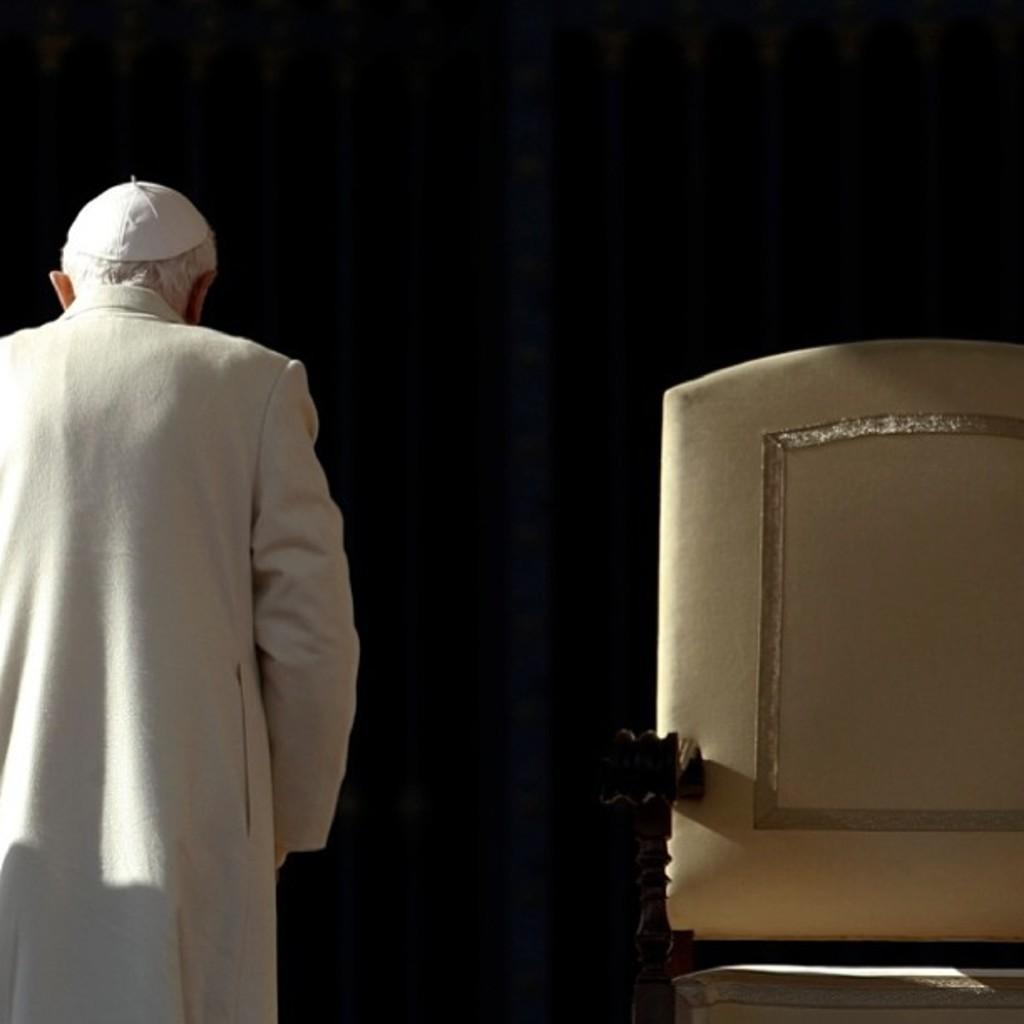What is the main subject of the image? The main subject of the image is a man standing. What is the man wearing on his head? The man is wearing a cap. What type of clothing is the man wearing on his upper body? The man is wearing a kurta. Can you describe any furniture in the image? There appears to be a chair in the image. What is the color scheme of the background in the image? The background of the image is dark. What type of linen is draped over the bead in the image? There is no linen or bead present in the image. How is the rake being used in the image? There is no rake present in the image. 